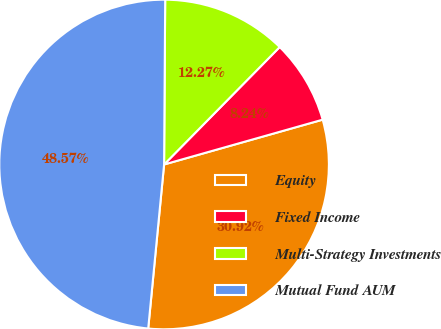<chart> <loc_0><loc_0><loc_500><loc_500><pie_chart><fcel>Equity<fcel>Fixed Income<fcel>Multi-Strategy Investments<fcel>Mutual Fund AUM<nl><fcel>30.92%<fcel>8.24%<fcel>12.27%<fcel>48.57%<nl></chart> 